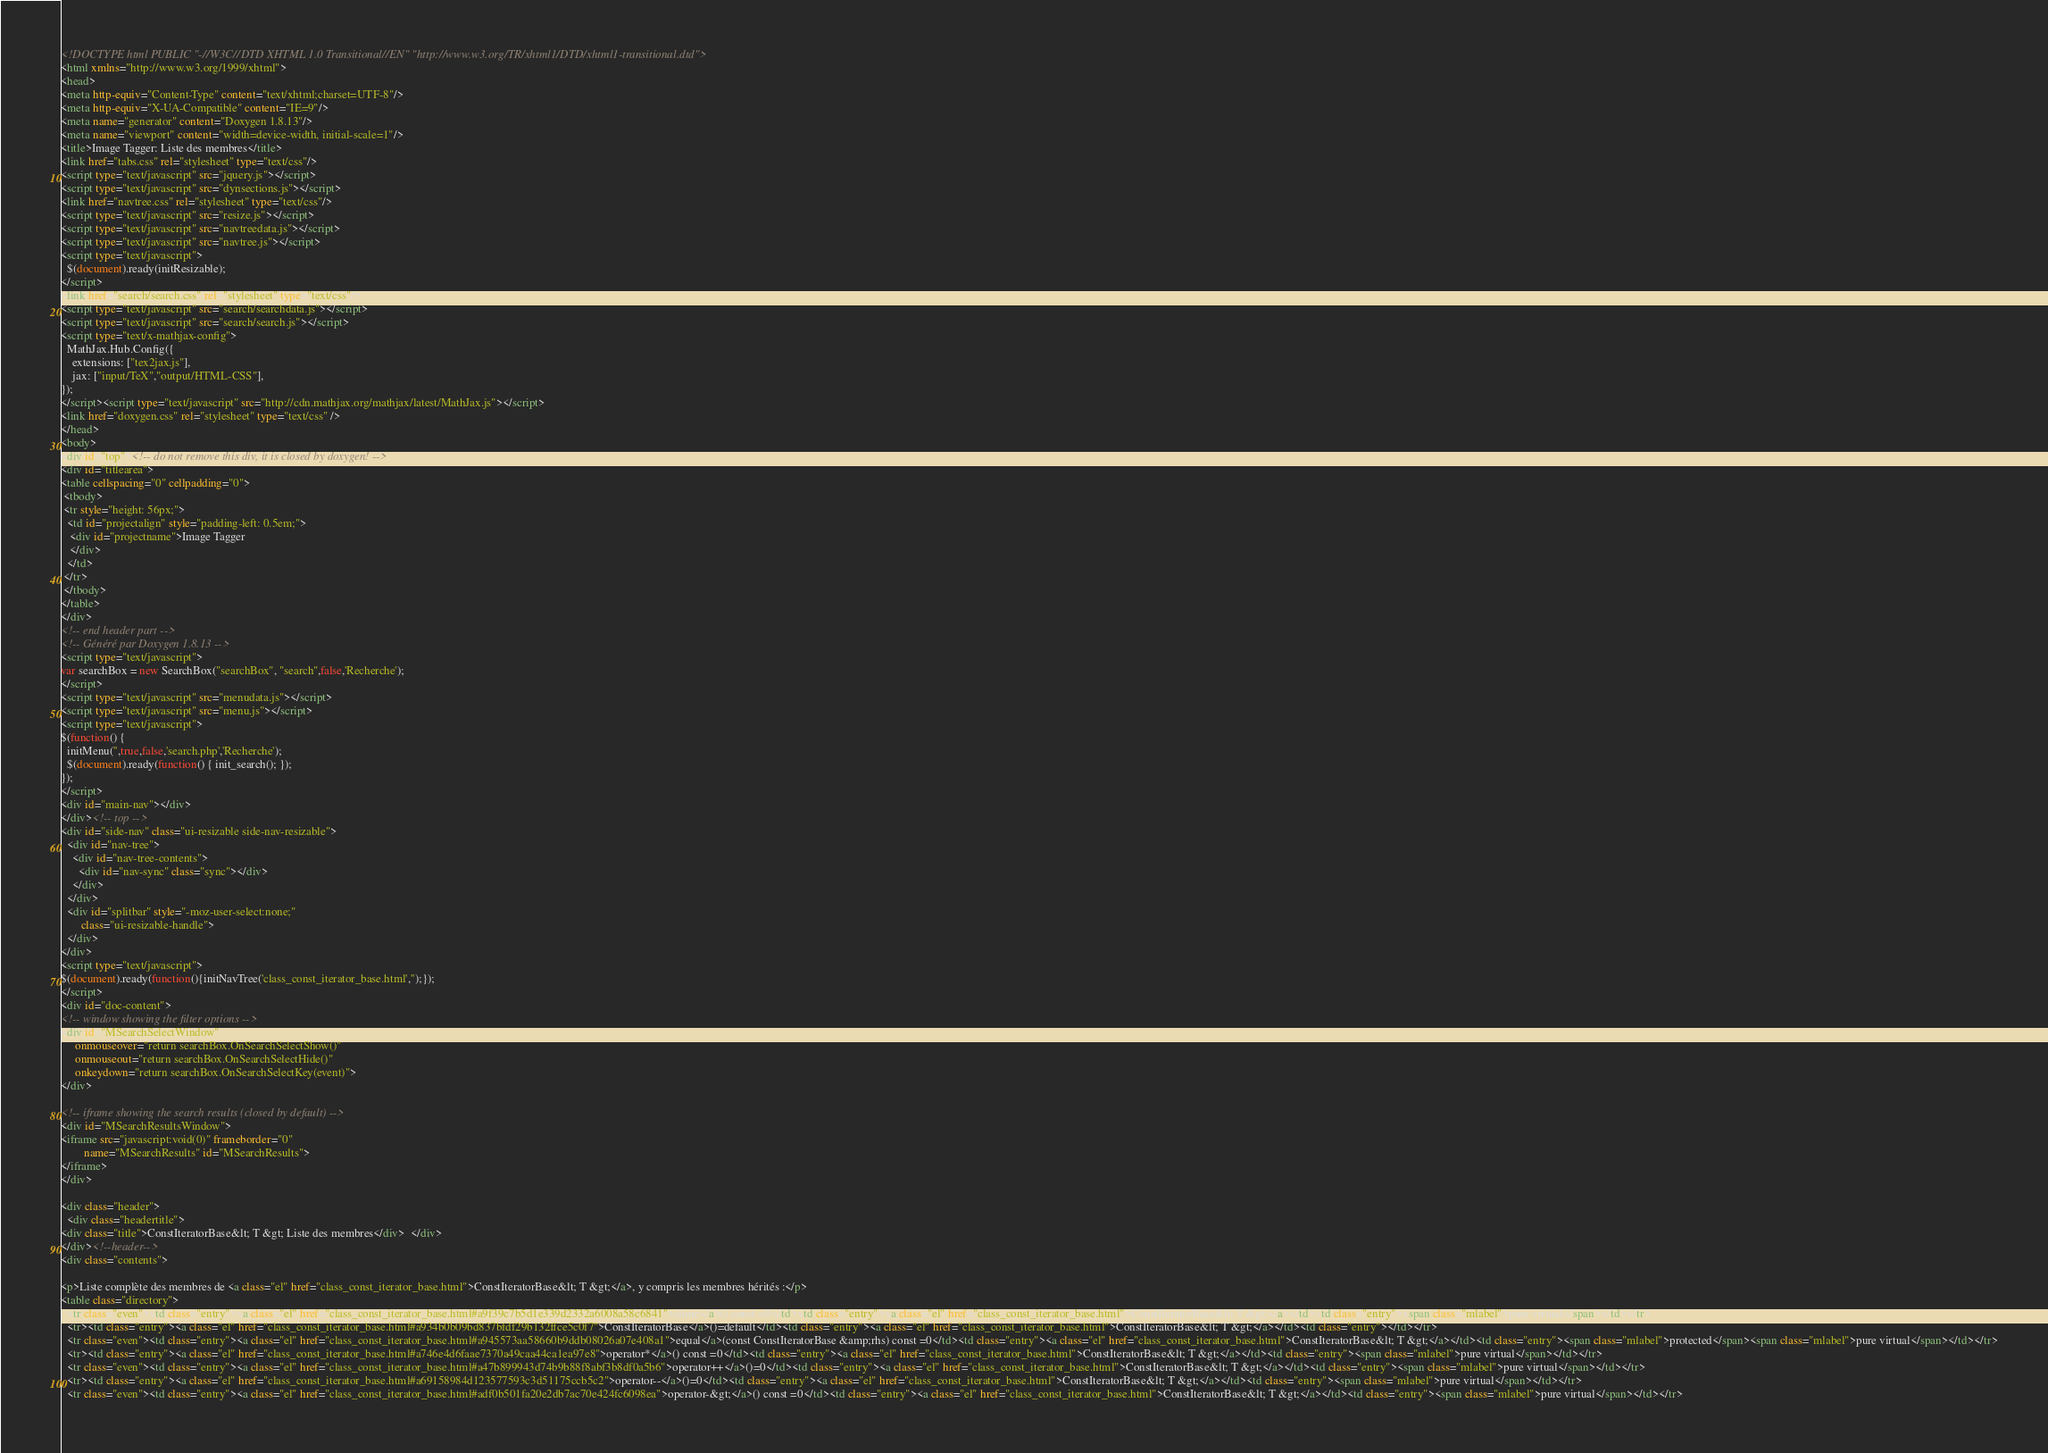<code> <loc_0><loc_0><loc_500><loc_500><_HTML_><!DOCTYPE html PUBLIC "-//W3C//DTD XHTML 1.0 Transitional//EN" "http://www.w3.org/TR/xhtml1/DTD/xhtml1-transitional.dtd">
<html xmlns="http://www.w3.org/1999/xhtml">
<head>
<meta http-equiv="Content-Type" content="text/xhtml;charset=UTF-8"/>
<meta http-equiv="X-UA-Compatible" content="IE=9"/>
<meta name="generator" content="Doxygen 1.8.13"/>
<meta name="viewport" content="width=device-width, initial-scale=1"/>
<title>Image Tagger: Liste des membres</title>
<link href="tabs.css" rel="stylesheet" type="text/css"/>
<script type="text/javascript" src="jquery.js"></script>
<script type="text/javascript" src="dynsections.js"></script>
<link href="navtree.css" rel="stylesheet" type="text/css"/>
<script type="text/javascript" src="resize.js"></script>
<script type="text/javascript" src="navtreedata.js"></script>
<script type="text/javascript" src="navtree.js"></script>
<script type="text/javascript">
  $(document).ready(initResizable);
</script>
<link href="search/search.css" rel="stylesheet" type="text/css"/>
<script type="text/javascript" src="search/searchdata.js"></script>
<script type="text/javascript" src="search/search.js"></script>
<script type="text/x-mathjax-config">
  MathJax.Hub.Config({
    extensions: ["tex2jax.js"],
    jax: ["input/TeX","output/HTML-CSS"],
});
</script><script type="text/javascript" src="http://cdn.mathjax.org/mathjax/latest/MathJax.js"></script>
<link href="doxygen.css" rel="stylesheet" type="text/css" />
</head>
<body>
<div id="top"><!-- do not remove this div, it is closed by doxygen! -->
<div id="titlearea">
<table cellspacing="0" cellpadding="0">
 <tbody>
 <tr style="height: 56px;">
  <td id="projectalign" style="padding-left: 0.5em;">
   <div id="projectname">Image Tagger
   </div>
  </td>
 </tr>
 </tbody>
</table>
</div>
<!-- end header part -->
<!-- Généré par Doxygen 1.8.13 -->
<script type="text/javascript">
var searchBox = new SearchBox("searchBox", "search",false,'Recherche');
</script>
<script type="text/javascript" src="menudata.js"></script>
<script type="text/javascript" src="menu.js"></script>
<script type="text/javascript">
$(function() {
  initMenu('',true,false,'search.php','Recherche');
  $(document).ready(function() { init_search(); });
});
</script>
<div id="main-nav"></div>
</div><!-- top -->
<div id="side-nav" class="ui-resizable side-nav-resizable">
  <div id="nav-tree">
    <div id="nav-tree-contents">
      <div id="nav-sync" class="sync"></div>
    </div>
  </div>
  <div id="splitbar" style="-moz-user-select:none;" 
       class="ui-resizable-handle">
  </div>
</div>
<script type="text/javascript">
$(document).ready(function(){initNavTree('class_const_iterator_base.html','');});
</script>
<div id="doc-content">
<!-- window showing the filter options -->
<div id="MSearchSelectWindow"
     onmouseover="return searchBox.OnSearchSelectShow()"
     onmouseout="return searchBox.OnSearchSelectHide()"
     onkeydown="return searchBox.OnSearchSelectKey(event)">
</div>

<!-- iframe showing the search results (closed by default) -->
<div id="MSearchResultsWindow">
<iframe src="javascript:void(0)" frameborder="0" 
        name="MSearchResults" id="MSearchResults">
</iframe>
</div>

<div class="header">
  <div class="headertitle">
<div class="title">ConstIteratorBase&lt; T &gt; Liste des membres</div>  </div>
</div><!--header-->
<div class="contents">

<p>Liste complète des membres de <a class="el" href="class_const_iterator_base.html">ConstIteratorBase&lt; T &gt;</a>, y compris les membres hérités :</p>
<table class="directory">
  <tr class="even"><td class="entry"><a class="el" href="class_const_iterator_base.html#a9f39c7b5d1e339d2332a6008a58c6841">clone</a>() const =0</td><td class="entry"><a class="el" href="class_const_iterator_base.html">ConstIteratorBase&lt; T &gt;</a></td><td class="entry"><span class="mlabel">pure virtual</span></td></tr>
  <tr><td class="entry"><a class="el" href="class_const_iterator_base.html#a934b0b09bd837bfdf29b132ffce5c0f7">ConstIteratorBase</a>()=default</td><td class="entry"><a class="el" href="class_const_iterator_base.html">ConstIteratorBase&lt; T &gt;</a></td><td class="entry"></td></tr>
  <tr class="even"><td class="entry"><a class="el" href="class_const_iterator_base.html#a945573aa58660b9ddb08026a07e408a1">equal</a>(const ConstIteratorBase &amp;rhs) const =0</td><td class="entry"><a class="el" href="class_const_iterator_base.html">ConstIteratorBase&lt; T &gt;</a></td><td class="entry"><span class="mlabel">protected</span><span class="mlabel">pure virtual</span></td></tr>
  <tr><td class="entry"><a class="el" href="class_const_iterator_base.html#a746e4d6faae7370a49caa44ca1ea97e8">operator*</a>() const =0</td><td class="entry"><a class="el" href="class_const_iterator_base.html">ConstIteratorBase&lt; T &gt;</a></td><td class="entry"><span class="mlabel">pure virtual</span></td></tr>
  <tr class="even"><td class="entry"><a class="el" href="class_const_iterator_base.html#a47b899943d74b9b88f8abf3b8df0a5b6">operator++</a>()=0</td><td class="entry"><a class="el" href="class_const_iterator_base.html">ConstIteratorBase&lt; T &gt;</a></td><td class="entry"><span class="mlabel">pure virtual</span></td></tr>
  <tr><td class="entry"><a class="el" href="class_const_iterator_base.html#a69158984d123577593c3d51175ccb5c2">operator--</a>()=0</td><td class="entry"><a class="el" href="class_const_iterator_base.html">ConstIteratorBase&lt; T &gt;</a></td><td class="entry"><span class="mlabel">pure virtual</span></td></tr>
  <tr class="even"><td class="entry"><a class="el" href="class_const_iterator_base.html#adf0b501fa20e2db7ac70e424fc6098ea">operator-&gt;</a>() const =0</td><td class="entry"><a class="el" href="class_const_iterator_base.html">ConstIteratorBase&lt; T &gt;</a></td><td class="entry"><span class="mlabel">pure virtual</span></td></tr></code> 